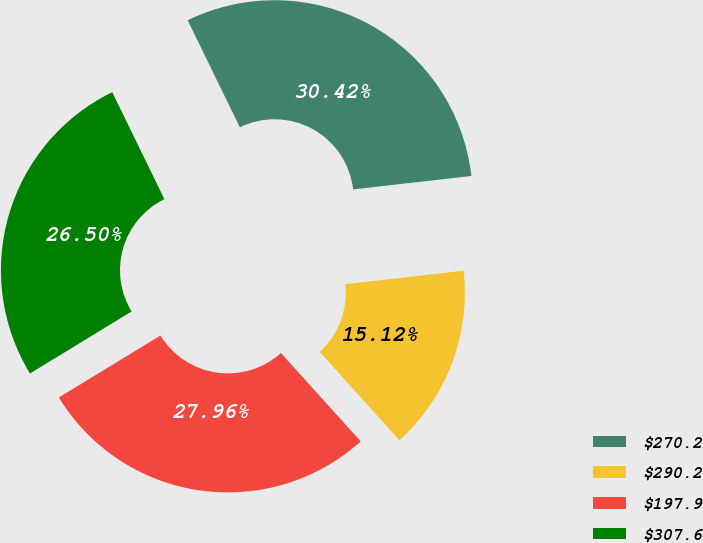Convert chart. <chart><loc_0><loc_0><loc_500><loc_500><pie_chart><fcel>$270.2<fcel>$290.2<fcel>$197.9<fcel>$307.6<nl><fcel>30.42%<fcel>15.12%<fcel>27.96%<fcel>26.5%<nl></chart> 